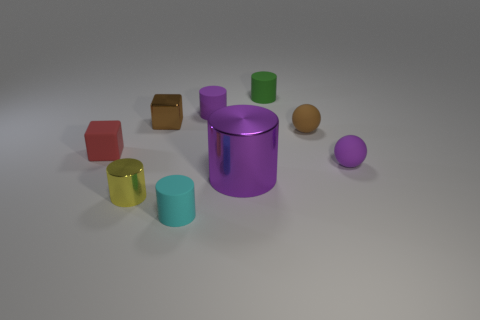The tiny purple thing on the left side of the large purple shiny thing has what shape?
Offer a very short reply. Cylinder. The tiny object that is on the right side of the ball to the left of the small purple sphere is what color?
Provide a short and direct response. Purple. What number of things are either cyan cylinders in front of the tiny matte block or tiny cyan matte objects?
Provide a short and direct response. 1. There is a brown metal block; does it have the same size as the cylinder that is to the right of the big purple metal thing?
Ensure brevity in your answer.  Yes. What number of small objects are either cyan cylinders or brown rubber objects?
Give a very brief answer. 2. There is a big metallic thing; what shape is it?
Offer a very short reply. Cylinder. What is the size of the rubber thing that is the same color as the small metal block?
Your answer should be compact. Small. Is there a small purple cylinder that has the same material as the large object?
Your answer should be very brief. No. Are there more metal cylinders than big red metal things?
Your answer should be very brief. Yes. Are the small purple cylinder and the small red thing made of the same material?
Give a very brief answer. Yes. 